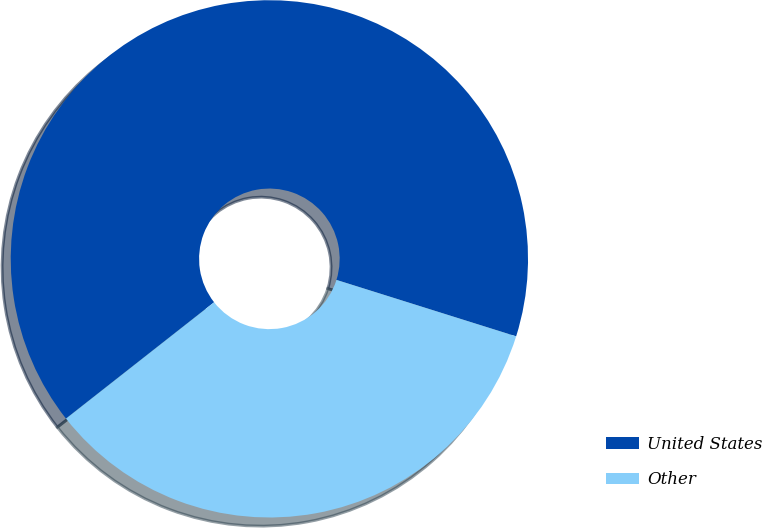Convert chart. <chart><loc_0><loc_0><loc_500><loc_500><pie_chart><fcel>United States<fcel>Other<nl><fcel>65.44%<fcel>34.56%<nl></chart> 